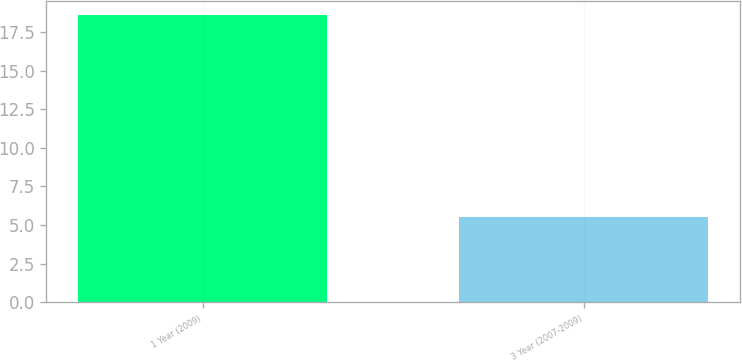<chart> <loc_0><loc_0><loc_500><loc_500><bar_chart><fcel>1 Year (2009)<fcel>3 Year (2007-2009)<nl><fcel>18.6<fcel>5.5<nl></chart> 